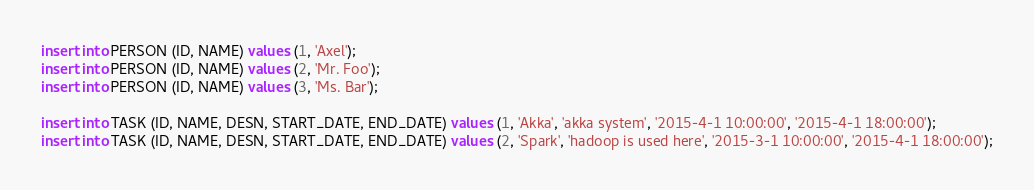<code> <loc_0><loc_0><loc_500><loc_500><_SQL_>insert into PERSON (ID, NAME) values (1, 'Axel');
insert into PERSON (ID, NAME) values (2, 'Mr. Foo');
insert into PERSON (ID, NAME) values (3, 'Ms. Bar');

insert into TASK (ID, NAME, DESN, START_DATE, END_DATE) values (1, 'Akka', 'akka system', '2015-4-1 10:00:00', '2015-4-1 18:00:00');
insert into TASK (ID, NAME, DESN, START_DATE, END_DATE) values (2, 'Spark', 'hadoop is used here', '2015-3-1 10:00:00', '2015-4-1 18:00:00');
</code> 